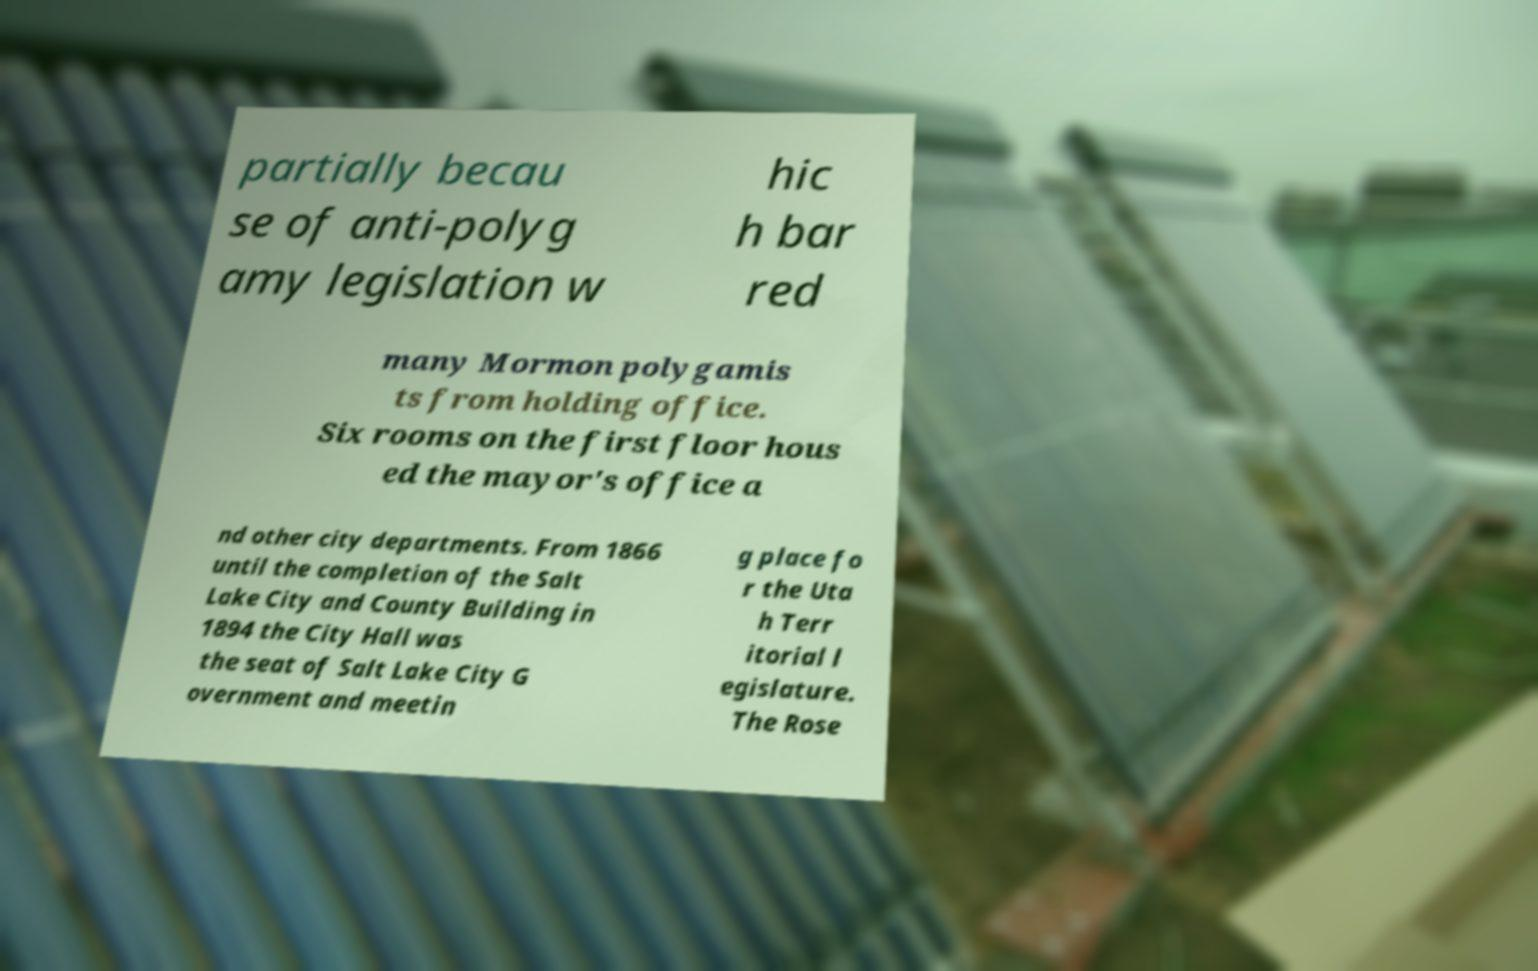I need the written content from this picture converted into text. Can you do that? partially becau se of anti-polyg amy legislation w hic h bar red many Mormon polygamis ts from holding office. Six rooms on the first floor hous ed the mayor's office a nd other city departments. From 1866 until the completion of the Salt Lake City and County Building in 1894 the City Hall was the seat of Salt Lake City G overnment and meetin g place fo r the Uta h Terr itorial l egislature. The Rose 